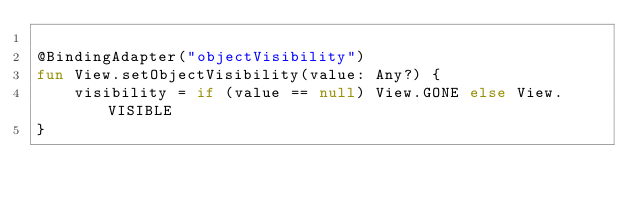<code> <loc_0><loc_0><loc_500><loc_500><_Kotlin_>
@BindingAdapter("objectVisibility")
fun View.setObjectVisibility(value: Any?) {
    visibility = if (value == null) View.GONE else View.VISIBLE
}</code> 